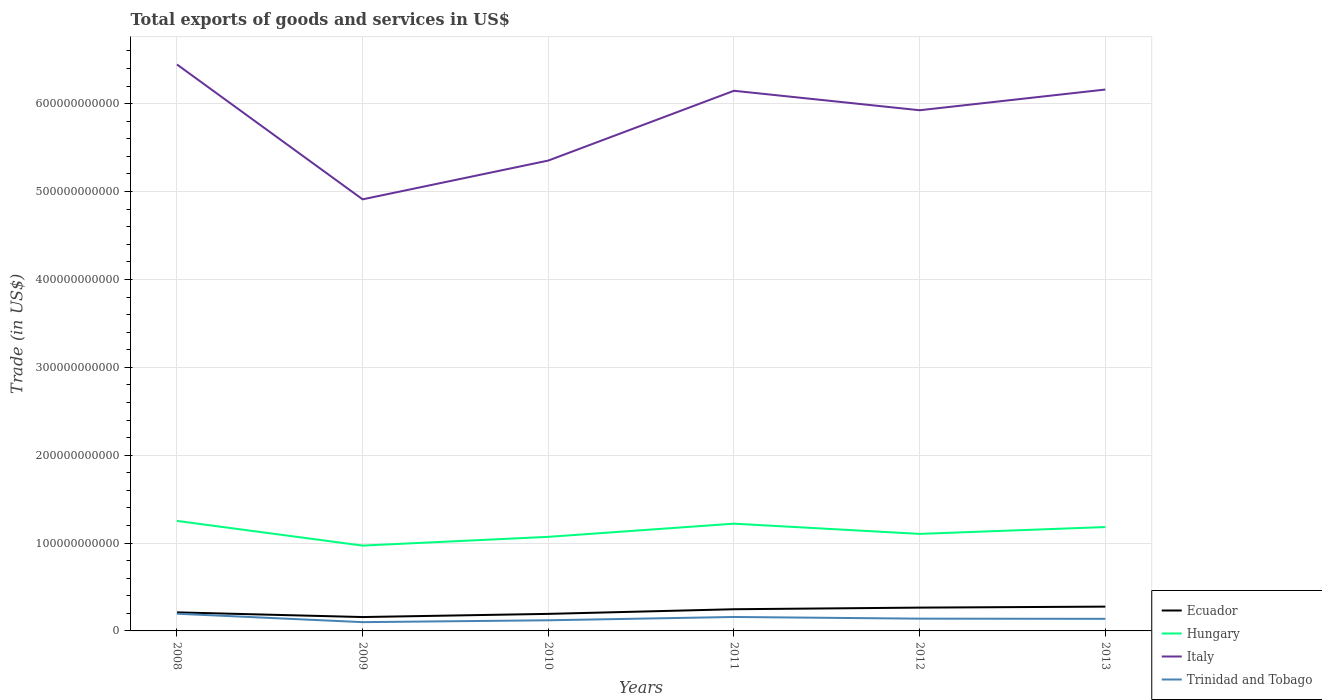How many different coloured lines are there?
Ensure brevity in your answer.  4. Does the line corresponding to Trinidad and Tobago intersect with the line corresponding to Hungary?
Your answer should be very brief. No. Is the number of lines equal to the number of legend labels?
Your response must be concise. Yes. Across all years, what is the maximum total exports of goods and services in Italy?
Your answer should be compact. 4.91e+11. What is the total total exports of goods and services in Italy in the graph?
Offer a terse response. -1.25e+11. What is the difference between the highest and the second highest total exports of goods and services in Ecuador?
Ensure brevity in your answer.  1.19e+1. Is the total exports of goods and services in Italy strictly greater than the total exports of goods and services in Ecuador over the years?
Offer a very short reply. No. What is the difference between two consecutive major ticks on the Y-axis?
Keep it short and to the point. 1.00e+11. Are the values on the major ticks of Y-axis written in scientific E-notation?
Your response must be concise. No. How many legend labels are there?
Offer a terse response. 4. How are the legend labels stacked?
Your answer should be compact. Vertical. What is the title of the graph?
Your answer should be compact. Total exports of goods and services in US$. What is the label or title of the Y-axis?
Your answer should be very brief. Trade (in US$). What is the Trade (in US$) in Ecuador in 2008?
Provide a short and direct response. 2.11e+1. What is the Trade (in US$) in Hungary in 2008?
Your answer should be very brief. 1.25e+11. What is the Trade (in US$) in Italy in 2008?
Ensure brevity in your answer.  6.45e+11. What is the Trade (in US$) of Trinidad and Tobago in 2008?
Provide a succinct answer. 1.96e+1. What is the Trade (in US$) in Ecuador in 2009?
Make the answer very short. 1.58e+1. What is the Trade (in US$) in Hungary in 2009?
Offer a terse response. 9.71e+1. What is the Trade (in US$) of Italy in 2009?
Ensure brevity in your answer.  4.91e+11. What is the Trade (in US$) in Trinidad and Tobago in 2009?
Offer a terse response. 9.99e+09. What is the Trade (in US$) in Ecuador in 2010?
Ensure brevity in your answer.  1.94e+1. What is the Trade (in US$) in Hungary in 2010?
Make the answer very short. 1.07e+11. What is the Trade (in US$) in Italy in 2010?
Keep it short and to the point. 5.35e+11. What is the Trade (in US$) of Trinidad and Tobago in 2010?
Make the answer very short. 1.21e+1. What is the Trade (in US$) of Ecuador in 2011?
Provide a short and direct response. 2.47e+1. What is the Trade (in US$) in Hungary in 2011?
Your response must be concise. 1.22e+11. What is the Trade (in US$) in Italy in 2011?
Your answer should be compact. 6.15e+11. What is the Trade (in US$) of Trinidad and Tobago in 2011?
Your answer should be very brief. 1.59e+1. What is the Trade (in US$) of Ecuador in 2012?
Ensure brevity in your answer.  2.65e+1. What is the Trade (in US$) of Hungary in 2012?
Provide a short and direct response. 1.10e+11. What is the Trade (in US$) of Italy in 2012?
Keep it short and to the point. 5.93e+11. What is the Trade (in US$) in Trinidad and Tobago in 2012?
Offer a very short reply. 1.40e+1. What is the Trade (in US$) in Ecuador in 2013?
Keep it short and to the point. 2.76e+1. What is the Trade (in US$) of Hungary in 2013?
Your response must be concise. 1.18e+11. What is the Trade (in US$) in Italy in 2013?
Your answer should be very brief. 6.16e+11. What is the Trade (in US$) of Trinidad and Tobago in 2013?
Provide a succinct answer. 1.38e+1. Across all years, what is the maximum Trade (in US$) of Ecuador?
Provide a short and direct response. 2.76e+1. Across all years, what is the maximum Trade (in US$) of Hungary?
Give a very brief answer. 1.25e+11. Across all years, what is the maximum Trade (in US$) of Italy?
Make the answer very short. 6.45e+11. Across all years, what is the maximum Trade (in US$) of Trinidad and Tobago?
Provide a short and direct response. 1.96e+1. Across all years, what is the minimum Trade (in US$) of Ecuador?
Make the answer very short. 1.58e+1. Across all years, what is the minimum Trade (in US$) of Hungary?
Ensure brevity in your answer.  9.71e+1. Across all years, what is the minimum Trade (in US$) of Italy?
Your answer should be compact. 4.91e+11. Across all years, what is the minimum Trade (in US$) in Trinidad and Tobago?
Your answer should be very brief. 9.99e+09. What is the total Trade (in US$) in Ecuador in the graph?
Ensure brevity in your answer.  1.35e+11. What is the total Trade (in US$) in Hungary in the graph?
Give a very brief answer. 6.80e+11. What is the total Trade (in US$) of Italy in the graph?
Your answer should be very brief. 3.49e+12. What is the total Trade (in US$) in Trinidad and Tobago in the graph?
Provide a short and direct response. 8.53e+1. What is the difference between the Trade (in US$) of Ecuador in 2008 and that in 2009?
Keep it short and to the point. 5.31e+09. What is the difference between the Trade (in US$) of Hungary in 2008 and that in 2009?
Give a very brief answer. 2.81e+1. What is the difference between the Trade (in US$) of Italy in 2008 and that in 2009?
Provide a succinct answer. 1.53e+11. What is the difference between the Trade (in US$) in Trinidad and Tobago in 2008 and that in 2009?
Give a very brief answer. 9.60e+09. What is the difference between the Trade (in US$) of Ecuador in 2008 and that in 2010?
Your answer should be very brief. 1.70e+09. What is the difference between the Trade (in US$) in Hungary in 2008 and that in 2010?
Your answer should be very brief. 1.81e+1. What is the difference between the Trade (in US$) of Italy in 2008 and that in 2010?
Your response must be concise. 1.09e+11. What is the difference between the Trade (in US$) of Trinidad and Tobago in 2008 and that in 2010?
Keep it short and to the point. 7.47e+09. What is the difference between the Trade (in US$) in Ecuador in 2008 and that in 2011?
Offer a very short reply. -3.57e+09. What is the difference between the Trade (in US$) of Hungary in 2008 and that in 2011?
Provide a short and direct response. 3.14e+09. What is the difference between the Trade (in US$) of Italy in 2008 and that in 2011?
Provide a short and direct response. 2.99e+1. What is the difference between the Trade (in US$) of Trinidad and Tobago in 2008 and that in 2011?
Ensure brevity in your answer.  3.70e+09. What is the difference between the Trade (in US$) of Ecuador in 2008 and that in 2012?
Provide a short and direct response. -5.42e+09. What is the difference between the Trade (in US$) of Hungary in 2008 and that in 2012?
Make the answer very short. 1.48e+1. What is the difference between the Trade (in US$) in Italy in 2008 and that in 2012?
Ensure brevity in your answer.  5.21e+1. What is the difference between the Trade (in US$) of Trinidad and Tobago in 2008 and that in 2012?
Provide a short and direct response. 5.63e+09. What is the difference between the Trade (in US$) of Ecuador in 2008 and that in 2013?
Offer a terse response. -6.55e+09. What is the difference between the Trade (in US$) of Hungary in 2008 and that in 2013?
Keep it short and to the point. 6.97e+09. What is the difference between the Trade (in US$) in Italy in 2008 and that in 2013?
Keep it short and to the point. 2.85e+1. What is the difference between the Trade (in US$) of Trinidad and Tobago in 2008 and that in 2013?
Offer a very short reply. 5.82e+09. What is the difference between the Trade (in US$) of Ecuador in 2009 and that in 2010?
Offer a terse response. -3.62e+09. What is the difference between the Trade (in US$) of Hungary in 2009 and that in 2010?
Give a very brief answer. -9.97e+09. What is the difference between the Trade (in US$) of Italy in 2009 and that in 2010?
Provide a succinct answer. -4.41e+1. What is the difference between the Trade (in US$) in Trinidad and Tobago in 2009 and that in 2010?
Your answer should be compact. -2.13e+09. What is the difference between the Trade (in US$) of Ecuador in 2009 and that in 2011?
Your response must be concise. -8.89e+09. What is the difference between the Trade (in US$) of Hungary in 2009 and that in 2011?
Give a very brief answer. -2.50e+1. What is the difference between the Trade (in US$) of Italy in 2009 and that in 2011?
Your answer should be very brief. -1.24e+11. What is the difference between the Trade (in US$) in Trinidad and Tobago in 2009 and that in 2011?
Ensure brevity in your answer.  -5.90e+09. What is the difference between the Trade (in US$) in Ecuador in 2009 and that in 2012?
Your answer should be very brief. -1.07e+1. What is the difference between the Trade (in US$) in Hungary in 2009 and that in 2012?
Give a very brief answer. -1.33e+1. What is the difference between the Trade (in US$) in Italy in 2009 and that in 2012?
Your answer should be very brief. -1.01e+11. What is the difference between the Trade (in US$) in Trinidad and Tobago in 2009 and that in 2012?
Offer a very short reply. -3.96e+09. What is the difference between the Trade (in US$) of Ecuador in 2009 and that in 2013?
Your answer should be very brief. -1.19e+1. What is the difference between the Trade (in US$) of Hungary in 2009 and that in 2013?
Provide a short and direct response. -2.11e+1. What is the difference between the Trade (in US$) in Italy in 2009 and that in 2013?
Your response must be concise. -1.25e+11. What is the difference between the Trade (in US$) in Trinidad and Tobago in 2009 and that in 2013?
Ensure brevity in your answer.  -3.77e+09. What is the difference between the Trade (in US$) in Ecuador in 2010 and that in 2011?
Offer a terse response. -5.27e+09. What is the difference between the Trade (in US$) of Hungary in 2010 and that in 2011?
Keep it short and to the point. -1.50e+1. What is the difference between the Trade (in US$) in Italy in 2010 and that in 2011?
Offer a terse response. -7.94e+1. What is the difference between the Trade (in US$) in Trinidad and Tobago in 2010 and that in 2011?
Keep it short and to the point. -3.77e+09. What is the difference between the Trade (in US$) in Ecuador in 2010 and that in 2012?
Offer a terse response. -7.12e+09. What is the difference between the Trade (in US$) of Hungary in 2010 and that in 2012?
Provide a short and direct response. -3.35e+09. What is the difference between the Trade (in US$) of Italy in 2010 and that in 2012?
Your answer should be very brief. -5.72e+1. What is the difference between the Trade (in US$) in Trinidad and Tobago in 2010 and that in 2012?
Your response must be concise. -1.84e+09. What is the difference between the Trade (in US$) in Ecuador in 2010 and that in 2013?
Provide a succinct answer. -8.24e+09. What is the difference between the Trade (in US$) in Hungary in 2010 and that in 2013?
Your answer should be very brief. -1.12e+1. What is the difference between the Trade (in US$) of Italy in 2010 and that in 2013?
Your answer should be compact. -8.08e+1. What is the difference between the Trade (in US$) of Trinidad and Tobago in 2010 and that in 2013?
Your response must be concise. -1.65e+09. What is the difference between the Trade (in US$) in Ecuador in 2011 and that in 2012?
Offer a very short reply. -1.85e+09. What is the difference between the Trade (in US$) of Hungary in 2011 and that in 2012?
Offer a terse response. 1.16e+1. What is the difference between the Trade (in US$) in Italy in 2011 and that in 2012?
Provide a short and direct response. 2.22e+1. What is the difference between the Trade (in US$) of Trinidad and Tobago in 2011 and that in 2012?
Your answer should be compact. 1.94e+09. What is the difference between the Trade (in US$) in Ecuador in 2011 and that in 2013?
Keep it short and to the point. -2.97e+09. What is the difference between the Trade (in US$) of Hungary in 2011 and that in 2013?
Ensure brevity in your answer.  3.84e+09. What is the difference between the Trade (in US$) of Italy in 2011 and that in 2013?
Ensure brevity in your answer.  -1.40e+09. What is the difference between the Trade (in US$) of Trinidad and Tobago in 2011 and that in 2013?
Ensure brevity in your answer.  2.12e+09. What is the difference between the Trade (in US$) of Ecuador in 2012 and that in 2013?
Provide a succinct answer. -1.12e+09. What is the difference between the Trade (in US$) in Hungary in 2012 and that in 2013?
Ensure brevity in your answer.  -7.80e+09. What is the difference between the Trade (in US$) of Italy in 2012 and that in 2013?
Provide a succinct answer. -2.36e+1. What is the difference between the Trade (in US$) of Trinidad and Tobago in 2012 and that in 2013?
Offer a terse response. 1.88e+08. What is the difference between the Trade (in US$) of Ecuador in 2008 and the Trade (in US$) of Hungary in 2009?
Offer a terse response. -7.60e+1. What is the difference between the Trade (in US$) of Ecuador in 2008 and the Trade (in US$) of Italy in 2009?
Your answer should be compact. -4.70e+11. What is the difference between the Trade (in US$) in Ecuador in 2008 and the Trade (in US$) in Trinidad and Tobago in 2009?
Keep it short and to the point. 1.11e+1. What is the difference between the Trade (in US$) in Hungary in 2008 and the Trade (in US$) in Italy in 2009?
Give a very brief answer. -3.66e+11. What is the difference between the Trade (in US$) in Hungary in 2008 and the Trade (in US$) in Trinidad and Tobago in 2009?
Ensure brevity in your answer.  1.15e+11. What is the difference between the Trade (in US$) in Italy in 2008 and the Trade (in US$) in Trinidad and Tobago in 2009?
Provide a short and direct response. 6.35e+11. What is the difference between the Trade (in US$) in Ecuador in 2008 and the Trade (in US$) in Hungary in 2010?
Your answer should be compact. -8.60e+1. What is the difference between the Trade (in US$) in Ecuador in 2008 and the Trade (in US$) in Italy in 2010?
Provide a succinct answer. -5.14e+11. What is the difference between the Trade (in US$) in Ecuador in 2008 and the Trade (in US$) in Trinidad and Tobago in 2010?
Your answer should be very brief. 8.99e+09. What is the difference between the Trade (in US$) of Hungary in 2008 and the Trade (in US$) of Italy in 2010?
Offer a very short reply. -4.10e+11. What is the difference between the Trade (in US$) of Hungary in 2008 and the Trade (in US$) of Trinidad and Tobago in 2010?
Offer a terse response. 1.13e+11. What is the difference between the Trade (in US$) in Italy in 2008 and the Trade (in US$) in Trinidad and Tobago in 2010?
Offer a terse response. 6.33e+11. What is the difference between the Trade (in US$) of Ecuador in 2008 and the Trade (in US$) of Hungary in 2011?
Your answer should be compact. -1.01e+11. What is the difference between the Trade (in US$) of Ecuador in 2008 and the Trade (in US$) of Italy in 2011?
Keep it short and to the point. -5.94e+11. What is the difference between the Trade (in US$) of Ecuador in 2008 and the Trade (in US$) of Trinidad and Tobago in 2011?
Keep it short and to the point. 5.21e+09. What is the difference between the Trade (in US$) of Hungary in 2008 and the Trade (in US$) of Italy in 2011?
Offer a terse response. -4.90e+11. What is the difference between the Trade (in US$) in Hungary in 2008 and the Trade (in US$) in Trinidad and Tobago in 2011?
Offer a terse response. 1.09e+11. What is the difference between the Trade (in US$) of Italy in 2008 and the Trade (in US$) of Trinidad and Tobago in 2011?
Offer a very short reply. 6.29e+11. What is the difference between the Trade (in US$) in Ecuador in 2008 and the Trade (in US$) in Hungary in 2012?
Give a very brief answer. -8.93e+1. What is the difference between the Trade (in US$) in Ecuador in 2008 and the Trade (in US$) in Italy in 2012?
Your answer should be compact. -5.71e+11. What is the difference between the Trade (in US$) of Ecuador in 2008 and the Trade (in US$) of Trinidad and Tobago in 2012?
Provide a short and direct response. 7.15e+09. What is the difference between the Trade (in US$) in Hungary in 2008 and the Trade (in US$) in Italy in 2012?
Your answer should be compact. -4.67e+11. What is the difference between the Trade (in US$) in Hungary in 2008 and the Trade (in US$) in Trinidad and Tobago in 2012?
Ensure brevity in your answer.  1.11e+11. What is the difference between the Trade (in US$) of Italy in 2008 and the Trade (in US$) of Trinidad and Tobago in 2012?
Your response must be concise. 6.31e+11. What is the difference between the Trade (in US$) in Ecuador in 2008 and the Trade (in US$) in Hungary in 2013?
Give a very brief answer. -9.71e+1. What is the difference between the Trade (in US$) of Ecuador in 2008 and the Trade (in US$) of Italy in 2013?
Ensure brevity in your answer.  -5.95e+11. What is the difference between the Trade (in US$) in Ecuador in 2008 and the Trade (in US$) in Trinidad and Tobago in 2013?
Ensure brevity in your answer.  7.34e+09. What is the difference between the Trade (in US$) of Hungary in 2008 and the Trade (in US$) of Italy in 2013?
Your answer should be compact. -4.91e+11. What is the difference between the Trade (in US$) in Hungary in 2008 and the Trade (in US$) in Trinidad and Tobago in 2013?
Give a very brief answer. 1.11e+11. What is the difference between the Trade (in US$) of Italy in 2008 and the Trade (in US$) of Trinidad and Tobago in 2013?
Offer a very short reply. 6.31e+11. What is the difference between the Trade (in US$) in Ecuador in 2009 and the Trade (in US$) in Hungary in 2010?
Provide a short and direct response. -9.13e+1. What is the difference between the Trade (in US$) in Ecuador in 2009 and the Trade (in US$) in Italy in 2010?
Make the answer very short. -5.20e+11. What is the difference between the Trade (in US$) in Ecuador in 2009 and the Trade (in US$) in Trinidad and Tobago in 2010?
Ensure brevity in your answer.  3.67e+09. What is the difference between the Trade (in US$) in Hungary in 2009 and the Trade (in US$) in Italy in 2010?
Offer a very short reply. -4.38e+11. What is the difference between the Trade (in US$) in Hungary in 2009 and the Trade (in US$) in Trinidad and Tobago in 2010?
Your answer should be very brief. 8.50e+1. What is the difference between the Trade (in US$) of Italy in 2009 and the Trade (in US$) of Trinidad and Tobago in 2010?
Your response must be concise. 4.79e+11. What is the difference between the Trade (in US$) in Ecuador in 2009 and the Trade (in US$) in Hungary in 2011?
Provide a short and direct response. -1.06e+11. What is the difference between the Trade (in US$) in Ecuador in 2009 and the Trade (in US$) in Italy in 2011?
Your response must be concise. -5.99e+11. What is the difference between the Trade (in US$) in Ecuador in 2009 and the Trade (in US$) in Trinidad and Tobago in 2011?
Make the answer very short. -1.00e+08. What is the difference between the Trade (in US$) of Hungary in 2009 and the Trade (in US$) of Italy in 2011?
Offer a terse response. -5.18e+11. What is the difference between the Trade (in US$) of Hungary in 2009 and the Trade (in US$) of Trinidad and Tobago in 2011?
Provide a short and direct response. 8.12e+1. What is the difference between the Trade (in US$) in Italy in 2009 and the Trade (in US$) in Trinidad and Tobago in 2011?
Keep it short and to the point. 4.75e+11. What is the difference between the Trade (in US$) in Ecuador in 2009 and the Trade (in US$) in Hungary in 2012?
Offer a very short reply. -9.46e+1. What is the difference between the Trade (in US$) in Ecuador in 2009 and the Trade (in US$) in Italy in 2012?
Provide a succinct answer. -5.77e+11. What is the difference between the Trade (in US$) of Ecuador in 2009 and the Trade (in US$) of Trinidad and Tobago in 2012?
Give a very brief answer. 1.84e+09. What is the difference between the Trade (in US$) in Hungary in 2009 and the Trade (in US$) in Italy in 2012?
Offer a terse response. -4.95e+11. What is the difference between the Trade (in US$) of Hungary in 2009 and the Trade (in US$) of Trinidad and Tobago in 2012?
Provide a succinct answer. 8.32e+1. What is the difference between the Trade (in US$) of Italy in 2009 and the Trade (in US$) of Trinidad and Tobago in 2012?
Your answer should be compact. 4.77e+11. What is the difference between the Trade (in US$) of Ecuador in 2009 and the Trade (in US$) of Hungary in 2013?
Your response must be concise. -1.02e+11. What is the difference between the Trade (in US$) in Ecuador in 2009 and the Trade (in US$) in Italy in 2013?
Ensure brevity in your answer.  -6.00e+11. What is the difference between the Trade (in US$) of Ecuador in 2009 and the Trade (in US$) of Trinidad and Tobago in 2013?
Keep it short and to the point. 2.02e+09. What is the difference between the Trade (in US$) of Hungary in 2009 and the Trade (in US$) of Italy in 2013?
Your answer should be very brief. -5.19e+11. What is the difference between the Trade (in US$) in Hungary in 2009 and the Trade (in US$) in Trinidad and Tobago in 2013?
Provide a succinct answer. 8.33e+1. What is the difference between the Trade (in US$) in Italy in 2009 and the Trade (in US$) in Trinidad and Tobago in 2013?
Provide a short and direct response. 4.77e+11. What is the difference between the Trade (in US$) in Ecuador in 2010 and the Trade (in US$) in Hungary in 2011?
Offer a very short reply. -1.03e+11. What is the difference between the Trade (in US$) in Ecuador in 2010 and the Trade (in US$) in Italy in 2011?
Make the answer very short. -5.95e+11. What is the difference between the Trade (in US$) of Ecuador in 2010 and the Trade (in US$) of Trinidad and Tobago in 2011?
Provide a short and direct response. 3.52e+09. What is the difference between the Trade (in US$) in Hungary in 2010 and the Trade (in US$) in Italy in 2011?
Make the answer very short. -5.08e+11. What is the difference between the Trade (in US$) in Hungary in 2010 and the Trade (in US$) in Trinidad and Tobago in 2011?
Provide a succinct answer. 9.12e+1. What is the difference between the Trade (in US$) of Italy in 2010 and the Trade (in US$) of Trinidad and Tobago in 2011?
Your answer should be compact. 5.19e+11. What is the difference between the Trade (in US$) in Ecuador in 2010 and the Trade (in US$) in Hungary in 2012?
Your response must be concise. -9.10e+1. What is the difference between the Trade (in US$) in Ecuador in 2010 and the Trade (in US$) in Italy in 2012?
Offer a very short reply. -5.73e+11. What is the difference between the Trade (in US$) in Ecuador in 2010 and the Trade (in US$) in Trinidad and Tobago in 2012?
Offer a terse response. 5.45e+09. What is the difference between the Trade (in US$) in Hungary in 2010 and the Trade (in US$) in Italy in 2012?
Offer a terse response. -4.85e+11. What is the difference between the Trade (in US$) in Hungary in 2010 and the Trade (in US$) in Trinidad and Tobago in 2012?
Offer a terse response. 9.31e+1. What is the difference between the Trade (in US$) in Italy in 2010 and the Trade (in US$) in Trinidad and Tobago in 2012?
Your response must be concise. 5.21e+11. What is the difference between the Trade (in US$) of Ecuador in 2010 and the Trade (in US$) of Hungary in 2013?
Your answer should be compact. -9.88e+1. What is the difference between the Trade (in US$) in Ecuador in 2010 and the Trade (in US$) in Italy in 2013?
Offer a terse response. -5.97e+11. What is the difference between the Trade (in US$) in Ecuador in 2010 and the Trade (in US$) in Trinidad and Tobago in 2013?
Provide a short and direct response. 5.64e+09. What is the difference between the Trade (in US$) of Hungary in 2010 and the Trade (in US$) of Italy in 2013?
Make the answer very short. -5.09e+11. What is the difference between the Trade (in US$) in Hungary in 2010 and the Trade (in US$) in Trinidad and Tobago in 2013?
Provide a succinct answer. 9.33e+1. What is the difference between the Trade (in US$) in Italy in 2010 and the Trade (in US$) in Trinidad and Tobago in 2013?
Give a very brief answer. 5.22e+11. What is the difference between the Trade (in US$) in Ecuador in 2011 and the Trade (in US$) in Hungary in 2012?
Provide a succinct answer. -8.57e+1. What is the difference between the Trade (in US$) of Ecuador in 2011 and the Trade (in US$) of Italy in 2012?
Your answer should be very brief. -5.68e+11. What is the difference between the Trade (in US$) of Ecuador in 2011 and the Trade (in US$) of Trinidad and Tobago in 2012?
Provide a short and direct response. 1.07e+1. What is the difference between the Trade (in US$) of Hungary in 2011 and the Trade (in US$) of Italy in 2012?
Offer a very short reply. -4.70e+11. What is the difference between the Trade (in US$) of Hungary in 2011 and the Trade (in US$) of Trinidad and Tobago in 2012?
Provide a succinct answer. 1.08e+11. What is the difference between the Trade (in US$) in Italy in 2011 and the Trade (in US$) in Trinidad and Tobago in 2012?
Provide a succinct answer. 6.01e+11. What is the difference between the Trade (in US$) of Ecuador in 2011 and the Trade (in US$) of Hungary in 2013?
Give a very brief answer. -9.35e+1. What is the difference between the Trade (in US$) of Ecuador in 2011 and the Trade (in US$) of Italy in 2013?
Keep it short and to the point. -5.91e+11. What is the difference between the Trade (in US$) of Ecuador in 2011 and the Trade (in US$) of Trinidad and Tobago in 2013?
Your response must be concise. 1.09e+1. What is the difference between the Trade (in US$) in Hungary in 2011 and the Trade (in US$) in Italy in 2013?
Offer a very short reply. -4.94e+11. What is the difference between the Trade (in US$) of Hungary in 2011 and the Trade (in US$) of Trinidad and Tobago in 2013?
Offer a terse response. 1.08e+11. What is the difference between the Trade (in US$) in Italy in 2011 and the Trade (in US$) in Trinidad and Tobago in 2013?
Ensure brevity in your answer.  6.01e+11. What is the difference between the Trade (in US$) of Ecuador in 2012 and the Trade (in US$) of Hungary in 2013?
Offer a very short reply. -9.17e+1. What is the difference between the Trade (in US$) in Ecuador in 2012 and the Trade (in US$) in Italy in 2013?
Ensure brevity in your answer.  -5.90e+11. What is the difference between the Trade (in US$) of Ecuador in 2012 and the Trade (in US$) of Trinidad and Tobago in 2013?
Offer a terse response. 1.28e+1. What is the difference between the Trade (in US$) of Hungary in 2012 and the Trade (in US$) of Italy in 2013?
Provide a succinct answer. -5.06e+11. What is the difference between the Trade (in US$) in Hungary in 2012 and the Trade (in US$) in Trinidad and Tobago in 2013?
Your answer should be very brief. 9.67e+1. What is the difference between the Trade (in US$) in Italy in 2012 and the Trade (in US$) in Trinidad and Tobago in 2013?
Provide a short and direct response. 5.79e+11. What is the average Trade (in US$) of Ecuador per year?
Your answer should be very brief. 2.25e+1. What is the average Trade (in US$) of Hungary per year?
Offer a very short reply. 1.13e+11. What is the average Trade (in US$) in Italy per year?
Give a very brief answer. 5.82e+11. What is the average Trade (in US$) of Trinidad and Tobago per year?
Give a very brief answer. 1.42e+1. In the year 2008, what is the difference between the Trade (in US$) of Ecuador and Trade (in US$) of Hungary?
Your answer should be compact. -1.04e+11. In the year 2008, what is the difference between the Trade (in US$) of Ecuador and Trade (in US$) of Italy?
Provide a succinct answer. -6.24e+11. In the year 2008, what is the difference between the Trade (in US$) of Ecuador and Trade (in US$) of Trinidad and Tobago?
Your answer should be very brief. 1.52e+09. In the year 2008, what is the difference between the Trade (in US$) of Hungary and Trade (in US$) of Italy?
Keep it short and to the point. -5.19e+11. In the year 2008, what is the difference between the Trade (in US$) in Hungary and Trade (in US$) in Trinidad and Tobago?
Provide a short and direct response. 1.06e+11. In the year 2008, what is the difference between the Trade (in US$) in Italy and Trade (in US$) in Trinidad and Tobago?
Your answer should be compact. 6.25e+11. In the year 2009, what is the difference between the Trade (in US$) in Ecuador and Trade (in US$) in Hungary?
Ensure brevity in your answer.  -8.13e+1. In the year 2009, what is the difference between the Trade (in US$) in Ecuador and Trade (in US$) in Italy?
Keep it short and to the point. -4.75e+11. In the year 2009, what is the difference between the Trade (in US$) of Ecuador and Trade (in US$) of Trinidad and Tobago?
Give a very brief answer. 5.80e+09. In the year 2009, what is the difference between the Trade (in US$) in Hungary and Trade (in US$) in Italy?
Your answer should be very brief. -3.94e+11. In the year 2009, what is the difference between the Trade (in US$) of Hungary and Trade (in US$) of Trinidad and Tobago?
Your response must be concise. 8.71e+1. In the year 2009, what is the difference between the Trade (in US$) of Italy and Trade (in US$) of Trinidad and Tobago?
Ensure brevity in your answer.  4.81e+11. In the year 2010, what is the difference between the Trade (in US$) in Ecuador and Trade (in US$) in Hungary?
Ensure brevity in your answer.  -8.77e+1. In the year 2010, what is the difference between the Trade (in US$) in Ecuador and Trade (in US$) in Italy?
Offer a very short reply. -5.16e+11. In the year 2010, what is the difference between the Trade (in US$) in Ecuador and Trade (in US$) in Trinidad and Tobago?
Make the answer very short. 7.29e+09. In the year 2010, what is the difference between the Trade (in US$) of Hungary and Trade (in US$) of Italy?
Your answer should be very brief. -4.28e+11. In the year 2010, what is the difference between the Trade (in US$) of Hungary and Trade (in US$) of Trinidad and Tobago?
Make the answer very short. 9.50e+1. In the year 2010, what is the difference between the Trade (in US$) in Italy and Trade (in US$) in Trinidad and Tobago?
Provide a succinct answer. 5.23e+11. In the year 2011, what is the difference between the Trade (in US$) in Ecuador and Trade (in US$) in Hungary?
Offer a terse response. -9.74e+1. In the year 2011, what is the difference between the Trade (in US$) of Ecuador and Trade (in US$) of Italy?
Provide a short and direct response. -5.90e+11. In the year 2011, what is the difference between the Trade (in US$) in Ecuador and Trade (in US$) in Trinidad and Tobago?
Your answer should be compact. 8.79e+09. In the year 2011, what is the difference between the Trade (in US$) in Hungary and Trade (in US$) in Italy?
Your answer should be very brief. -4.93e+11. In the year 2011, what is the difference between the Trade (in US$) of Hungary and Trade (in US$) of Trinidad and Tobago?
Give a very brief answer. 1.06e+11. In the year 2011, what is the difference between the Trade (in US$) in Italy and Trade (in US$) in Trinidad and Tobago?
Provide a short and direct response. 5.99e+11. In the year 2012, what is the difference between the Trade (in US$) of Ecuador and Trade (in US$) of Hungary?
Provide a short and direct response. -8.39e+1. In the year 2012, what is the difference between the Trade (in US$) of Ecuador and Trade (in US$) of Italy?
Offer a terse response. -5.66e+11. In the year 2012, what is the difference between the Trade (in US$) in Ecuador and Trade (in US$) in Trinidad and Tobago?
Provide a short and direct response. 1.26e+1. In the year 2012, what is the difference between the Trade (in US$) in Hungary and Trade (in US$) in Italy?
Give a very brief answer. -4.82e+11. In the year 2012, what is the difference between the Trade (in US$) in Hungary and Trade (in US$) in Trinidad and Tobago?
Make the answer very short. 9.65e+1. In the year 2012, what is the difference between the Trade (in US$) of Italy and Trade (in US$) of Trinidad and Tobago?
Ensure brevity in your answer.  5.79e+11. In the year 2013, what is the difference between the Trade (in US$) of Ecuador and Trade (in US$) of Hungary?
Ensure brevity in your answer.  -9.06e+1. In the year 2013, what is the difference between the Trade (in US$) of Ecuador and Trade (in US$) of Italy?
Your answer should be very brief. -5.88e+11. In the year 2013, what is the difference between the Trade (in US$) in Ecuador and Trade (in US$) in Trinidad and Tobago?
Provide a short and direct response. 1.39e+1. In the year 2013, what is the difference between the Trade (in US$) in Hungary and Trade (in US$) in Italy?
Your answer should be very brief. -4.98e+11. In the year 2013, what is the difference between the Trade (in US$) in Hungary and Trade (in US$) in Trinidad and Tobago?
Keep it short and to the point. 1.04e+11. In the year 2013, what is the difference between the Trade (in US$) in Italy and Trade (in US$) in Trinidad and Tobago?
Make the answer very short. 6.02e+11. What is the ratio of the Trade (in US$) in Ecuador in 2008 to that in 2009?
Give a very brief answer. 1.34. What is the ratio of the Trade (in US$) in Hungary in 2008 to that in 2009?
Offer a very short reply. 1.29. What is the ratio of the Trade (in US$) in Italy in 2008 to that in 2009?
Ensure brevity in your answer.  1.31. What is the ratio of the Trade (in US$) in Trinidad and Tobago in 2008 to that in 2009?
Your answer should be compact. 1.96. What is the ratio of the Trade (in US$) in Ecuador in 2008 to that in 2010?
Offer a very short reply. 1.09. What is the ratio of the Trade (in US$) of Hungary in 2008 to that in 2010?
Ensure brevity in your answer.  1.17. What is the ratio of the Trade (in US$) of Italy in 2008 to that in 2010?
Provide a short and direct response. 1.2. What is the ratio of the Trade (in US$) of Trinidad and Tobago in 2008 to that in 2010?
Offer a terse response. 1.62. What is the ratio of the Trade (in US$) in Ecuador in 2008 to that in 2011?
Provide a short and direct response. 0.86. What is the ratio of the Trade (in US$) of Hungary in 2008 to that in 2011?
Provide a short and direct response. 1.03. What is the ratio of the Trade (in US$) of Italy in 2008 to that in 2011?
Provide a succinct answer. 1.05. What is the ratio of the Trade (in US$) in Trinidad and Tobago in 2008 to that in 2011?
Offer a very short reply. 1.23. What is the ratio of the Trade (in US$) in Ecuador in 2008 to that in 2012?
Give a very brief answer. 0.8. What is the ratio of the Trade (in US$) of Hungary in 2008 to that in 2012?
Provide a succinct answer. 1.13. What is the ratio of the Trade (in US$) of Italy in 2008 to that in 2012?
Offer a terse response. 1.09. What is the ratio of the Trade (in US$) in Trinidad and Tobago in 2008 to that in 2012?
Your answer should be compact. 1.4. What is the ratio of the Trade (in US$) of Ecuador in 2008 to that in 2013?
Your answer should be very brief. 0.76. What is the ratio of the Trade (in US$) in Hungary in 2008 to that in 2013?
Ensure brevity in your answer.  1.06. What is the ratio of the Trade (in US$) of Italy in 2008 to that in 2013?
Provide a short and direct response. 1.05. What is the ratio of the Trade (in US$) of Trinidad and Tobago in 2008 to that in 2013?
Offer a terse response. 1.42. What is the ratio of the Trade (in US$) of Ecuador in 2009 to that in 2010?
Give a very brief answer. 0.81. What is the ratio of the Trade (in US$) of Hungary in 2009 to that in 2010?
Your answer should be compact. 0.91. What is the ratio of the Trade (in US$) in Italy in 2009 to that in 2010?
Offer a very short reply. 0.92. What is the ratio of the Trade (in US$) of Trinidad and Tobago in 2009 to that in 2010?
Keep it short and to the point. 0.82. What is the ratio of the Trade (in US$) in Ecuador in 2009 to that in 2011?
Give a very brief answer. 0.64. What is the ratio of the Trade (in US$) of Hungary in 2009 to that in 2011?
Provide a short and direct response. 0.8. What is the ratio of the Trade (in US$) of Italy in 2009 to that in 2011?
Make the answer very short. 0.8. What is the ratio of the Trade (in US$) in Trinidad and Tobago in 2009 to that in 2011?
Make the answer very short. 0.63. What is the ratio of the Trade (in US$) of Ecuador in 2009 to that in 2012?
Keep it short and to the point. 0.6. What is the ratio of the Trade (in US$) in Hungary in 2009 to that in 2012?
Make the answer very short. 0.88. What is the ratio of the Trade (in US$) of Italy in 2009 to that in 2012?
Offer a terse response. 0.83. What is the ratio of the Trade (in US$) in Trinidad and Tobago in 2009 to that in 2012?
Keep it short and to the point. 0.72. What is the ratio of the Trade (in US$) in Ecuador in 2009 to that in 2013?
Your answer should be compact. 0.57. What is the ratio of the Trade (in US$) of Hungary in 2009 to that in 2013?
Ensure brevity in your answer.  0.82. What is the ratio of the Trade (in US$) of Italy in 2009 to that in 2013?
Give a very brief answer. 0.8. What is the ratio of the Trade (in US$) in Trinidad and Tobago in 2009 to that in 2013?
Your response must be concise. 0.73. What is the ratio of the Trade (in US$) in Ecuador in 2010 to that in 2011?
Ensure brevity in your answer.  0.79. What is the ratio of the Trade (in US$) in Hungary in 2010 to that in 2011?
Your answer should be very brief. 0.88. What is the ratio of the Trade (in US$) of Italy in 2010 to that in 2011?
Keep it short and to the point. 0.87. What is the ratio of the Trade (in US$) of Trinidad and Tobago in 2010 to that in 2011?
Provide a short and direct response. 0.76. What is the ratio of the Trade (in US$) in Ecuador in 2010 to that in 2012?
Offer a very short reply. 0.73. What is the ratio of the Trade (in US$) in Hungary in 2010 to that in 2012?
Ensure brevity in your answer.  0.97. What is the ratio of the Trade (in US$) of Italy in 2010 to that in 2012?
Make the answer very short. 0.9. What is the ratio of the Trade (in US$) of Trinidad and Tobago in 2010 to that in 2012?
Offer a terse response. 0.87. What is the ratio of the Trade (in US$) in Ecuador in 2010 to that in 2013?
Provide a short and direct response. 0.7. What is the ratio of the Trade (in US$) in Hungary in 2010 to that in 2013?
Ensure brevity in your answer.  0.91. What is the ratio of the Trade (in US$) of Italy in 2010 to that in 2013?
Ensure brevity in your answer.  0.87. What is the ratio of the Trade (in US$) of Trinidad and Tobago in 2010 to that in 2013?
Provide a short and direct response. 0.88. What is the ratio of the Trade (in US$) in Ecuador in 2011 to that in 2012?
Ensure brevity in your answer.  0.93. What is the ratio of the Trade (in US$) of Hungary in 2011 to that in 2012?
Your answer should be very brief. 1.11. What is the ratio of the Trade (in US$) in Italy in 2011 to that in 2012?
Offer a terse response. 1.04. What is the ratio of the Trade (in US$) of Trinidad and Tobago in 2011 to that in 2012?
Offer a terse response. 1.14. What is the ratio of the Trade (in US$) in Ecuador in 2011 to that in 2013?
Your response must be concise. 0.89. What is the ratio of the Trade (in US$) of Hungary in 2011 to that in 2013?
Provide a short and direct response. 1.03. What is the ratio of the Trade (in US$) in Trinidad and Tobago in 2011 to that in 2013?
Ensure brevity in your answer.  1.15. What is the ratio of the Trade (in US$) of Ecuador in 2012 to that in 2013?
Ensure brevity in your answer.  0.96. What is the ratio of the Trade (in US$) in Hungary in 2012 to that in 2013?
Give a very brief answer. 0.93. What is the ratio of the Trade (in US$) of Italy in 2012 to that in 2013?
Keep it short and to the point. 0.96. What is the ratio of the Trade (in US$) in Trinidad and Tobago in 2012 to that in 2013?
Your answer should be very brief. 1.01. What is the difference between the highest and the second highest Trade (in US$) of Ecuador?
Your answer should be compact. 1.12e+09. What is the difference between the highest and the second highest Trade (in US$) in Hungary?
Offer a very short reply. 3.14e+09. What is the difference between the highest and the second highest Trade (in US$) in Italy?
Provide a succinct answer. 2.85e+1. What is the difference between the highest and the second highest Trade (in US$) in Trinidad and Tobago?
Your answer should be very brief. 3.70e+09. What is the difference between the highest and the lowest Trade (in US$) in Ecuador?
Offer a terse response. 1.19e+1. What is the difference between the highest and the lowest Trade (in US$) of Hungary?
Keep it short and to the point. 2.81e+1. What is the difference between the highest and the lowest Trade (in US$) in Italy?
Ensure brevity in your answer.  1.53e+11. What is the difference between the highest and the lowest Trade (in US$) of Trinidad and Tobago?
Provide a short and direct response. 9.60e+09. 